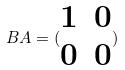Convert formula to latex. <formula><loc_0><loc_0><loc_500><loc_500>B A = ( \begin{matrix} 1 & 0 \\ 0 & 0 \end{matrix} )</formula> 